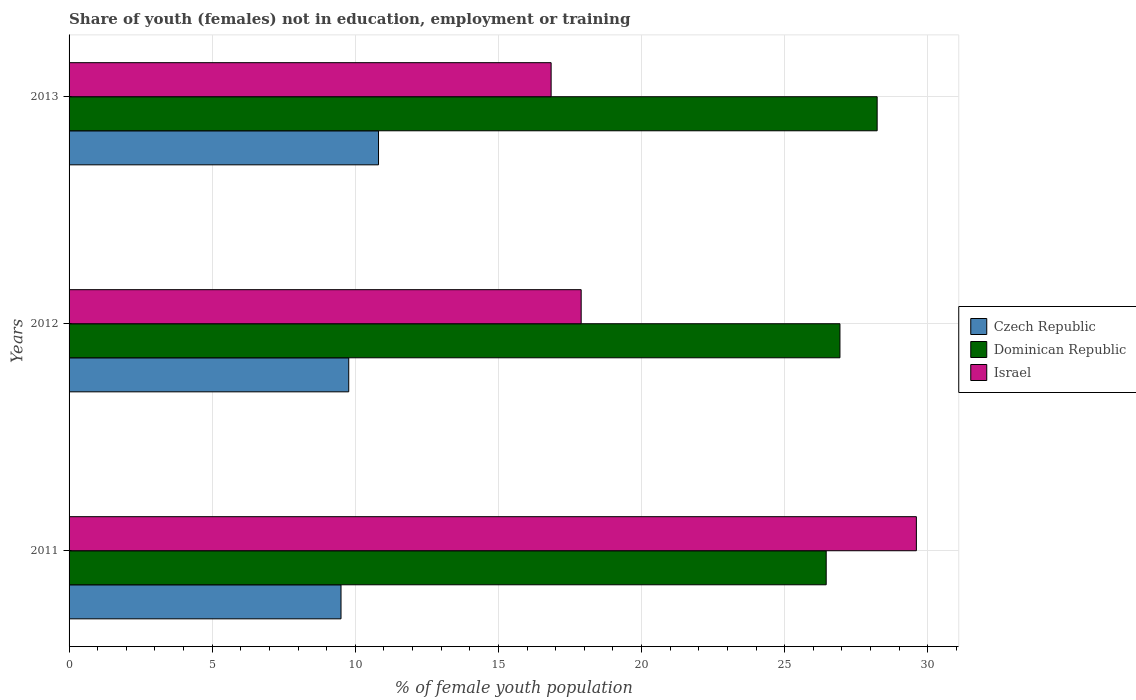How many different coloured bars are there?
Ensure brevity in your answer.  3. How many groups of bars are there?
Provide a succinct answer. 3. Are the number of bars on each tick of the Y-axis equal?
Make the answer very short. Yes. How many bars are there on the 3rd tick from the top?
Make the answer very short. 3. How many bars are there on the 1st tick from the bottom?
Your answer should be very brief. 3. In how many cases, is the number of bars for a given year not equal to the number of legend labels?
Make the answer very short. 0. What is the percentage of unemployed female population in in Dominican Republic in 2012?
Keep it short and to the point. 26.93. Across all years, what is the maximum percentage of unemployed female population in in Czech Republic?
Offer a very short reply. 10.81. Across all years, what is the minimum percentage of unemployed female population in in Czech Republic?
Make the answer very short. 9.5. In which year was the percentage of unemployed female population in in Dominican Republic maximum?
Your response must be concise. 2013. What is the total percentage of unemployed female population in in Israel in the graph?
Your response must be concise. 64.33. What is the difference between the percentage of unemployed female population in in Czech Republic in 2011 and that in 2013?
Your answer should be very brief. -1.31. What is the difference between the percentage of unemployed female population in in Dominican Republic in 2013 and the percentage of unemployed female population in in Czech Republic in 2012?
Your response must be concise. 18.46. What is the average percentage of unemployed female population in in Czech Republic per year?
Your answer should be very brief. 10.03. In the year 2013, what is the difference between the percentage of unemployed female population in in Dominican Republic and percentage of unemployed female population in in Israel?
Offer a very short reply. 11.39. What is the ratio of the percentage of unemployed female population in in Israel in 2011 to that in 2012?
Keep it short and to the point. 1.65. What is the difference between the highest and the second highest percentage of unemployed female population in in Israel?
Keep it short and to the point. 11.71. What is the difference between the highest and the lowest percentage of unemployed female population in in Czech Republic?
Keep it short and to the point. 1.31. In how many years, is the percentage of unemployed female population in in Israel greater than the average percentage of unemployed female population in in Israel taken over all years?
Offer a terse response. 1. Is the sum of the percentage of unemployed female population in in Dominican Republic in 2011 and 2012 greater than the maximum percentage of unemployed female population in in Israel across all years?
Provide a succinct answer. Yes. Is it the case that in every year, the sum of the percentage of unemployed female population in in Dominican Republic and percentage of unemployed female population in in Israel is greater than the percentage of unemployed female population in in Czech Republic?
Give a very brief answer. Yes. Does the graph contain grids?
Provide a succinct answer. Yes. Where does the legend appear in the graph?
Make the answer very short. Center right. How many legend labels are there?
Offer a very short reply. 3. What is the title of the graph?
Give a very brief answer. Share of youth (females) not in education, employment or training. What is the label or title of the X-axis?
Your answer should be compact. % of female youth population. What is the % of female youth population of Dominican Republic in 2011?
Make the answer very short. 26.45. What is the % of female youth population of Israel in 2011?
Keep it short and to the point. 29.6. What is the % of female youth population in Czech Republic in 2012?
Provide a short and direct response. 9.77. What is the % of female youth population in Dominican Republic in 2012?
Provide a succinct answer. 26.93. What is the % of female youth population in Israel in 2012?
Make the answer very short. 17.89. What is the % of female youth population in Czech Republic in 2013?
Keep it short and to the point. 10.81. What is the % of female youth population of Dominican Republic in 2013?
Your answer should be very brief. 28.23. What is the % of female youth population in Israel in 2013?
Your answer should be compact. 16.84. Across all years, what is the maximum % of female youth population of Czech Republic?
Make the answer very short. 10.81. Across all years, what is the maximum % of female youth population in Dominican Republic?
Your answer should be very brief. 28.23. Across all years, what is the maximum % of female youth population of Israel?
Your answer should be compact. 29.6. Across all years, what is the minimum % of female youth population of Czech Republic?
Your answer should be compact. 9.5. Across all years, what is the minimum % of female youth population in Dominican Republic?
Offer a terse response. 26.45. Across all years, what is the minimum % of female youth population in Israel?
Provide a succinct answer. 16.84. What is the total % of female youth population of Czech Republic in the graph?
Keep it short and to the point. 30.08. What is the total % of female youth population in Dominican Republic in the graph?
Provide a short and direct response. 81.61. What is the total % of female youth population in Israel in the graph?
Ensure brevity in your answer.  64.33. What is the difference between the % of female youth population of Czech Republic in 2011 and that in 2012?
Provide a succinct answer. -0.27. What is the difference between the % of female youth population of Dominican Republic in 2011 and that in 2012?
Your response must be concise. -0.48. What is the difference between the % of female youth population of Israel in 2011 and that in 2012?
Your answer should be very brief. 11.71. What is the difference between the % of female youth population in Czech Republic in 2011 and that in 2013?
Ensure brevity in your answer.  -1.31. What is the difference between the % of female youth population in Dominican Republic in 2011 and that in 2013?
Offer a terse response. -1.78. What is the difference between the % of female youth population in Israel in 2011 and that in 2013?
Offer a terse response. 12.76. What is the difference between the % of female youth population in Czech Republic in 2012 and that in 2013?
Keep it short and to the point. -1.04. What is the difference between the % of female youth population of Dominican Republic in 2012 and that in 2013?
Provide a short and direct response. -1.3. What is the difference between the % of female youth population in Czech Republic in 2011 and the % of female youth population in Dominican Republic in 2012?
Offer a terse response. -17.43. What is the difference between the % of female youth population of Czech Republic in 2011 and the % of female youth population of Israel in 2012?
Offer a terse response. -8.39. What is the difference between the % of female youth population of Dominican Republic in 2011 and the % of female youth population of Israel in 2012?
Offer a very short reply. 8.56. What is the difference between the % of female youth population in Czech Republic in 2011 and the % of female youth population in Dominican Republic in 2013?
Ensure brevity in your answer.  -18.73. What is the difference between the % of female youth population of Czech Republic in 2011 and the % of female youth population of Israel in 2013?
Your answer should be very brief. -7.34. What is the difference between the % of female youth population in Dominican Republic in 2011 and the % of female youth population in Israel in 2013?
Keep it short and to the point. 9.61. What is the difference between the % of female youth population of Czech Republic in 2012 and the % of female youth population of Dominican Republic in 2013?
Your response must be concise. -18.46. What is the difference between the % of female youth population of Czech Republic in 2012 and the % of female youth population of Israel in 2013?
Provide a succinct answer. -7.07. What is the difference between the % of female youth population in Dominican Republic in 2012 and the % of female youth population in Israel in 2013?
Keep it short and to the point. 10.09. What is the average % of female youth population in Czech Republic per year?
Provide a short and direct response. 10.03. What is the average % of female youth population in Dominican Republic per year?
Keep it short and to the point. 27.2. What is the average % of female youth population in Israel per year?
Keep it short and to the point. 21.44. In the year 2011, what is the difference between the % of female youth population of Czech Republic and % of female youth population of Dominican Republic?
Make the answer very short. -16.95. In the year 2011, what is the difference between the % of female youth population in Czech Republic and % of female youth population in Israel?
Your response must be concise. -20.1. In the year 2011, what is the difference between the % of female youth population of Dominican Republic and % of female youth population of Israel?
Keep it short and to the point. -3.15. In the year 2012, what is the difference between the % of female youth population of Czech Republic and % of female youth population of Dominican Republic?
Offer a very short reply. -17.16. In the year 2012, what is the difference between the % of female youth population in Czech Republic and % of female youth population in Israel?
Offer a terse response. -8.12. In the year 2012, what is the difference between the % of female youth population in Dominican Republic and % of female youth population in Israel?
Make the answer very short. 9.04. In the year 2013, what is the difference between the % of female youth population of Czech Republic and % of female youth population of Dominican Republic?
Make the answer very short. -17.42. In the year 2013, what is the difference between the % of female youth population of Czech Republic and % of female youth population of Israel?
Provide a short and direct response. -6.03. In the year 2013, what is the difference between the % of female youth population of Dominican Republic and % of female youth population of Israel?
Your response must be concise. 11.39. What is the ratio of the % of female youth population in Czech Republic in 2011 to that in 2012?
Ensure brevity in your answer.  0.97. What is the ratio of the % of female youth population of Dominican Republic in 2011 to that in 2012?
Ensure brevity in your answer.  0.98. What is the ratio of the % of female youth population in Israel in 2011 to that in 2012?
Keep it short and to the point. 1.65. What is the ratio of the % of female youth population in Czech Republic in 2011 to that in 2013?
Your answer should be very brief. 0.88. What is the ratio of the % of female youth population of Dominican Republic in 2011 to that in 2013?
Offer a terse response. 0.94. What is the ratio of the % of female youth population of Israel in 2011 to that in 2013?
Give a very brief answer. 1.76. What is the ratio of the % of female youth population in Czech Republic in 2012 to that in 2013?
Ensure brevity in your answer.  0.9. What is the ratio of the % of female youth population in Dominican Republic in 2012 to that in 2013?
Ensure brevity in your answer.  0.95. What is the ratio of the % of female youth population of Israel in 2012 to that in 2013?
Provide a short and direct response. 1.06. What is the difference between the highest and the second highest % of female youth population of Israel?
Make the answer very short. 11.71. What is the difference between the highest and the lowest % of female youth population in Czech Republic?
Offer a very short reply. 1.31. What is the difference between the highest and the lowest % of female youth population in Dominican Republic?
Your answer should be compact. 1.78. What is the difference between the highest and the lowest % of female youth population of Israel?
Make the answer very short. 12.76. 